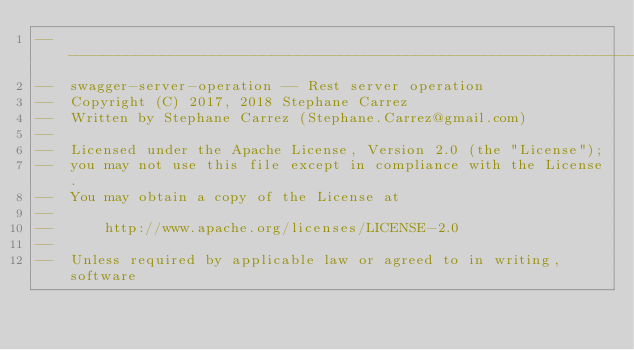Convert code to text. <code><loc_0><loc_0><loc_500><loc_500><_Ada_>-----------------------------------------------------------------------
--  swagger-server-operation -- Rest server operation
--  Copyright (C) 2017, 2018 Stephane Carrez
--  Written by Stephane Carrez (Stephane.Carrez@gmail.com)
--
--  Licensed under the Apache License, Version 2.0 (the "License");
--  you may not use this file except in compliance with the License.
--  You may obtain a copy of the License at
--
--      http://www.apache.org/licenses/LICENSE-2.0
--
--  Unless required by applicable law or agreed to in writing, software</code> 